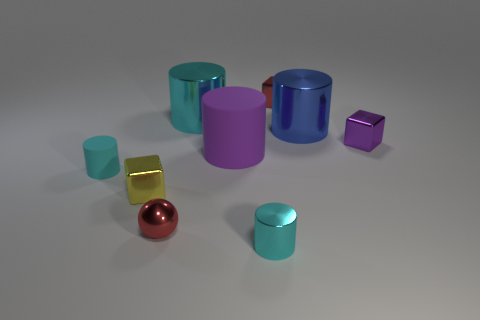Subtract all red metallic cubes. How many cubes are left? 2 Subtract all cyan cylinders. How many cylinders are left? 2 Subtract all red metal things. Subtract all tiny purple shiny things. How many objects are left? 6 Add 9 large purple matte cylinders. How many large purple matte cylinders are left? 10 Add 5 tiny red shiny balls. How many tiny red shiny balls exist? 6 Subtract 0 gray cubes. How many objects are left? 9 Subtract all blocks. How many objects are left? 6 Subtract 1 cylinders. How many cylinders are left? 4 Subtract all blue cylinders. Subtract all brown blocks. How many cylinders are left? 4 Subtract all cyan cubes. How many cyan cylinders are left? 3 